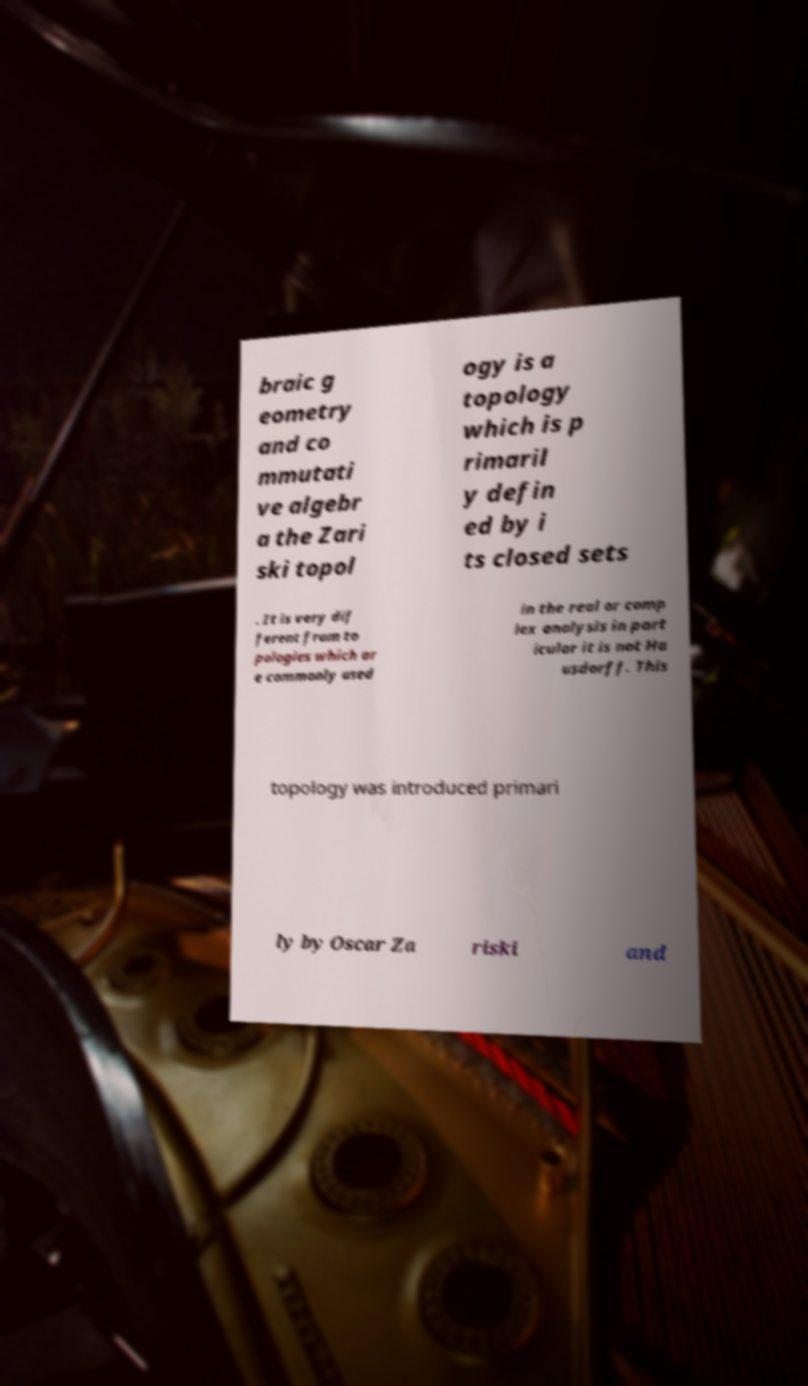Could you extract and type out the text from this image? braic g eometry and co mmutati ve algebr a the Zari ski topol ogy is a topology which is p rimaril y defin ed by i ts closed sets . It is very dif ferent from to pologies which ar e commonly used in the real or comp lex analysis in part icular it is not Ha usdorff. This topology was introduced primari ly by Oscar Za riski and 